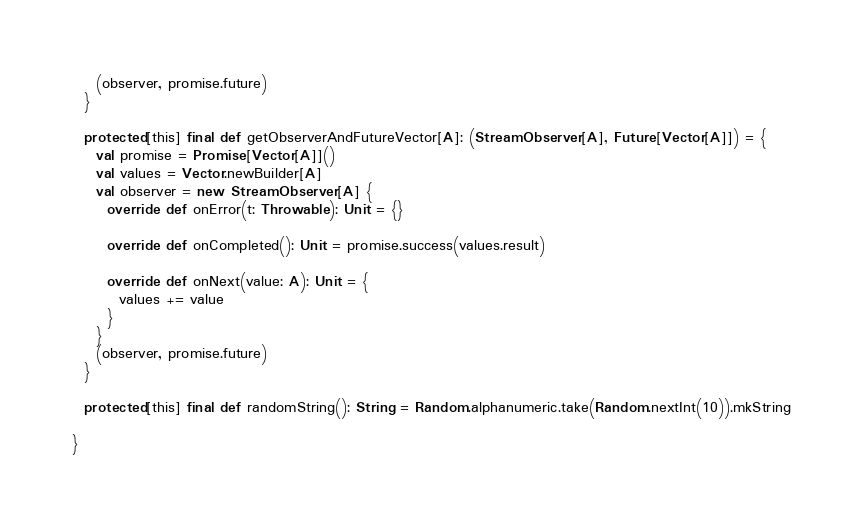Convert code to text. <code><loc_0><loc_0><loc_500><loc_500><_Scala_>    (observer, promise.future)
  }

  protected[this] final def getObserverAndFutureVector[A]: (StreamObserver[A], Future[Vector[A]]) = {
    val promise = Promise[Vector[A]]()
    val values = Vector.newBuilder[A]
    val observer = new StreamObserver[A] {
      override def onError(t: Throwable): Unit = {}

      override def onCompleted(): Unit = promise.success(values.result)

      override def onNext(value: A): Unit = {
        values += value
      }
    }
    (observer, promise.future)
  }

  protected[this] final def randomString(): String = Random.alphanumeric.take(Random.nextInt(10)).mkString

}
</code> 